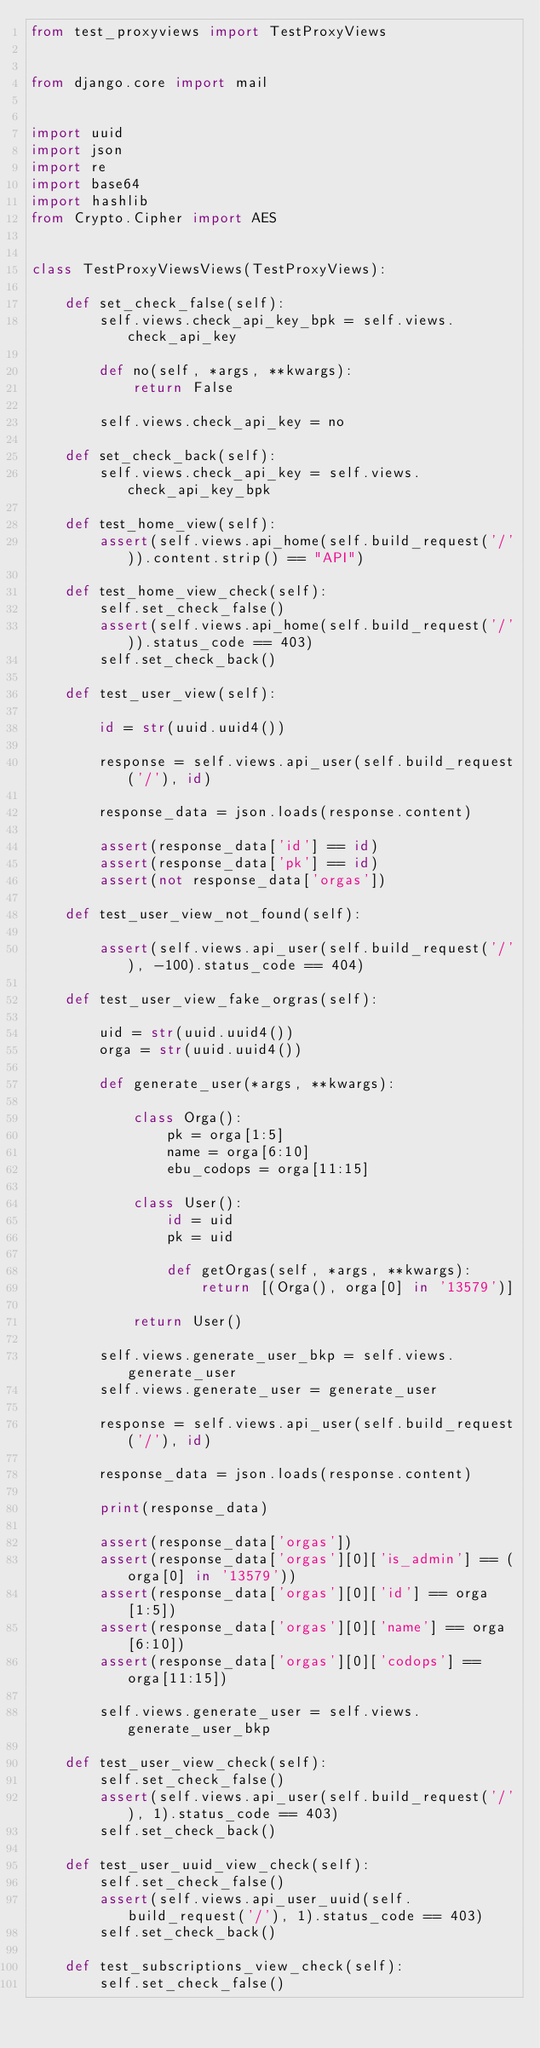<code> <loc_0><loc_0><loc_500><loc_500><_Python_>from test_proxyviews import TestProxyViews


from django.core import mail


import uuid
import json
import re
import base64
import hashlib
from Crypto.Cipher import AES


class TestProxyViewsViews(TestProxyViews):

    def set_check_false(self):
        self.views.check_api_key_bpk = self.views.check_api_key

        def no(self, *args, **kwargs):
            return False

        self.views.check_api_key = no

    def set_check_back(self):
        self.views.check_api_key = self.views.check_api_key_bpk

    def test_home_view(self):
        assert(self.views.api_home(self.build_request('/')).content.strip() == "API")

    def test_home_view_check(self):
        self.set_check_false()
        assert(self.views.api_home(self.build_request('/')).status_code == 403)
        self.set_check_back()

    def test_user_view(self):

        id = str(uuid.uuid4())

        response = self.views.api_user(self.build_request('/'), id)

        response_data = json.loads(response.content)

        assert(response_data['id'] == id)
        assert(response_data['pk'] == id)
        assert(not response_data['orgas'])

    def test_user_view_not_found(self):

        assert(self.views.api_user(self.build_request('/'), -100).status_code == 404)

    def test_user_view_fake_orgras(self):

        uid = str(uuid.uuid4())
        orga = str(uuid.uuid4())

        def generate_user(*args, **kwargs):

            class Orga():
                pk = orga[1:5]
                name = orga[6:10]
                ebu_codops = orga[11:15]

            class User():
                id = uid
                pk = uid

                def getOrgas(self, *args, **kwargs):
                    return [(Orga(), orga[0] in '13579')]

            return User()

        self.views.generate_user_bkp = self.views.generate_user
        self.views.generate_user = generate_user

        response = self.views.api_user(self.build_request('/'), id)

        response_data = json.loads(response.content)

        print(response_data)

        assert(response_data['orgas'])
        assert(response_data['orgas'][0]['is_admin'] == (orga[0] in '13579'))
        assert(response_data['orgas'][0]['id'] == orga[1:5])
        assert(response_data['orgas'][0]['name'] == orga[6:10])
        assert(response_data['orgas'][0]['codops'] == orga[11:15])

        self.views.generate_user = self.views.generate_user_bkp

    def test_user_view_check(self):
        self.set_check_false()
        assert(self.views.api_user(self.build_request('/'), 1).status_code == 403)
        self.set_check_back()

    def test_user_uuid_view_check(self):
        self.set_check_false()
        assert(self.views.api_user_uuid(self.build_request('/'), 1).status_code == 403)
        self.set_check_back()

    def test_subscriptions_view_check(self):
        self.set_check_false()</code> 